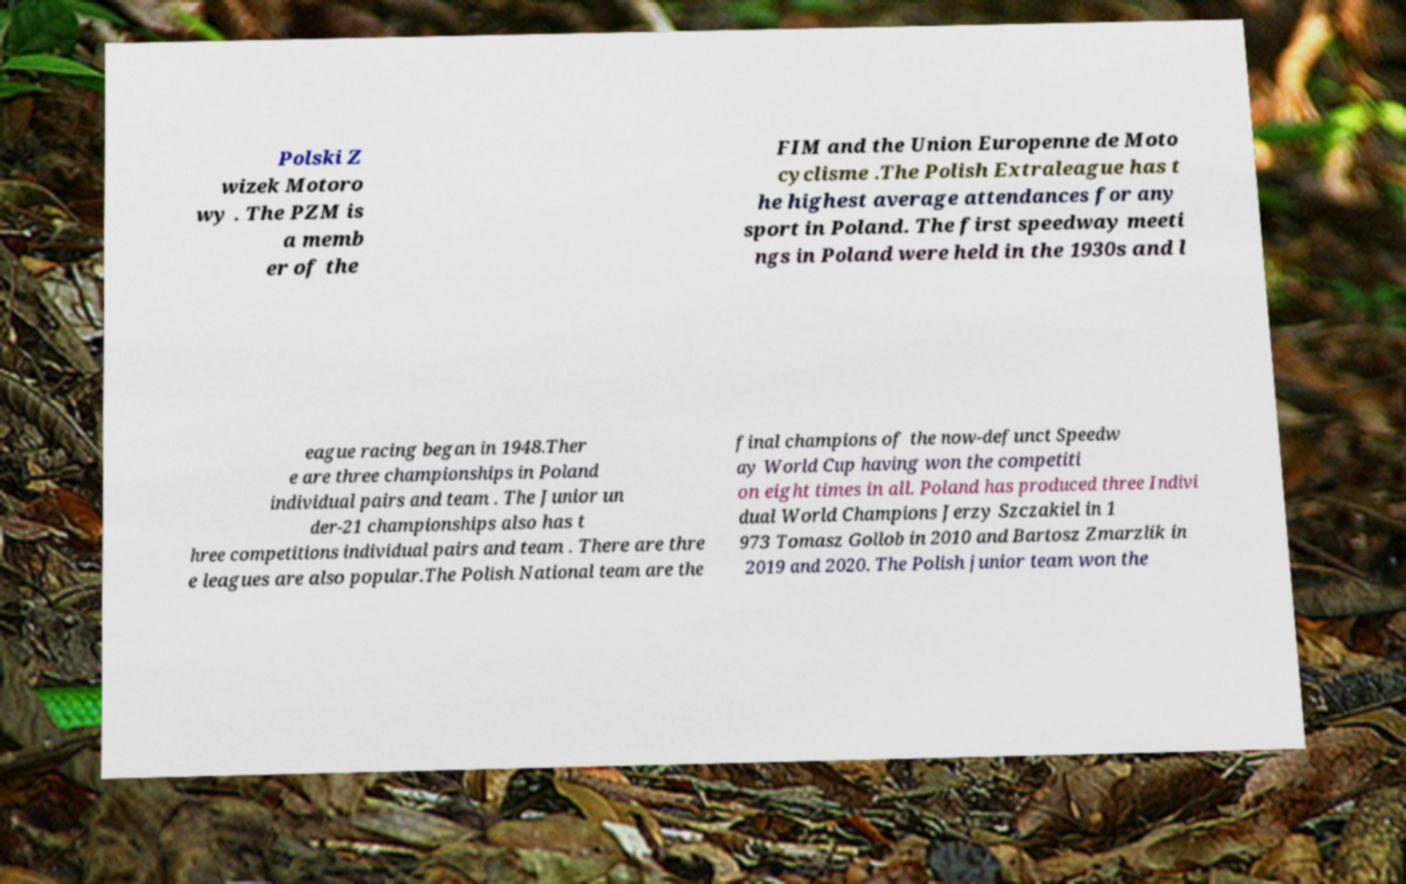What messages or text are displayed in this image? I need them in a readable, typed format. Polski Z wizek Motoro wy . The PZM is a memb er of the FIM and the Union Europenne de Moto cyclisme .The Polish Extraleague has t he highest average attendances for any sport in Poland. The first speedway meeti ngs in Poland were held in the 1930s and l eague racing began in 1948.Ther e are three championships in Poland individual pairs and team . The Junior un der-21 championships also has t hree competitions individual pairs and team . There are thre e leagues are also popular.The Polish National team are the final champions of the now-defunct Speedw ay World Cup having won the competiti on eight times in all. Poland has produced three Indivi dual World Champions Jerzy Szczakiel in 1 973 Tomasz Gollob in 2010 and Bartosz Zmarzlik in 2019 and 2020. The Polish junior team won the 